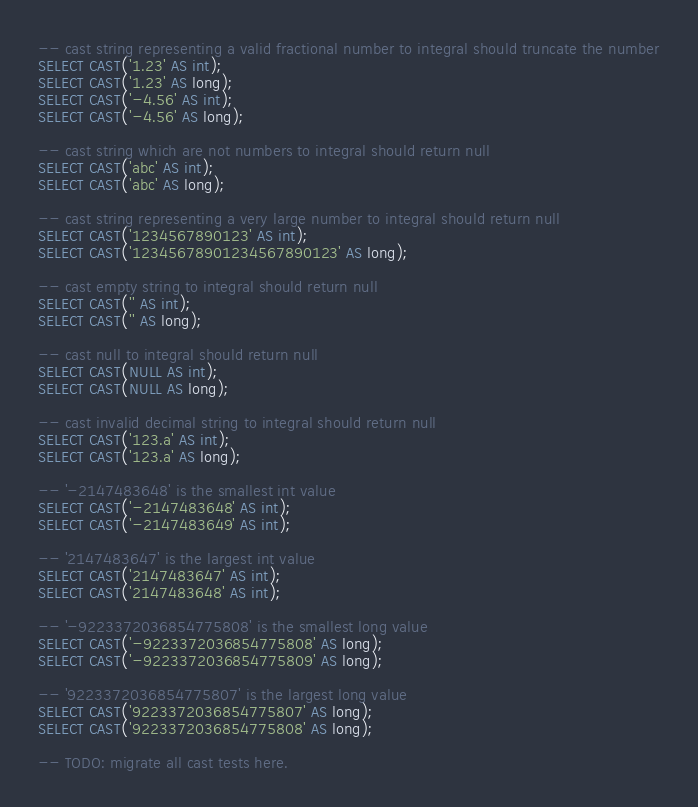<code> <loc_0><loc_0><loc_500><loc_500><_SQL_>-- cast string representing a valid fractional number to integral should truncate the number
SELECT CAST('1.23' AS int);
SELECT CAST('1.23' AS long);
SELECT CAST('-4.56' AS int);
SELECT CAST('-4.56' AS long);

-- cast string which are not numbers to integral should return null
SELECT CAST('abc' AS int);
SELECT CAST('abc' AS long);

-- cast string representing a very large number to integral should return null
SELECT CAST('1234567890123' AS int);
SELECT CAST('12345678901234567890123' AS long);

-- cast empty string to integral should return null
SELECT CAST('' AS int);
SELECT CAST('' AS long);

-- cast null to integral should return null
SELECT CAST(NULL AS int);
SELECT CAST(NULL AS long);

-- cast invalid decimal string to integral should return null
SELECT CAST('123.a' AS int);
SELECT CAST('123.a' AS long);

-- '-2147483648' is the smallest int value
SELECT CAST('-2147483648' AS int);
SELECT CAST('-2147483649' AS int);

-- '2147483647' is the largest int value
SELECT CAST('2147483647' AS int);
SELECT CAST('2147483648' AS int);

-- '-9223372036854775808' is the smallest long value
SELECT CAST('-9223372036854775808' AS long);
SELECT CAST('-9223372036854775809' AS long);

-- '9223372036854775807' is the largest long value
SELECT CAST('9223372036854775807' AS long);
SELECT CAST('9223372036854775808' AS long);

-- TODO: migrate all cast tests here.
</code> 